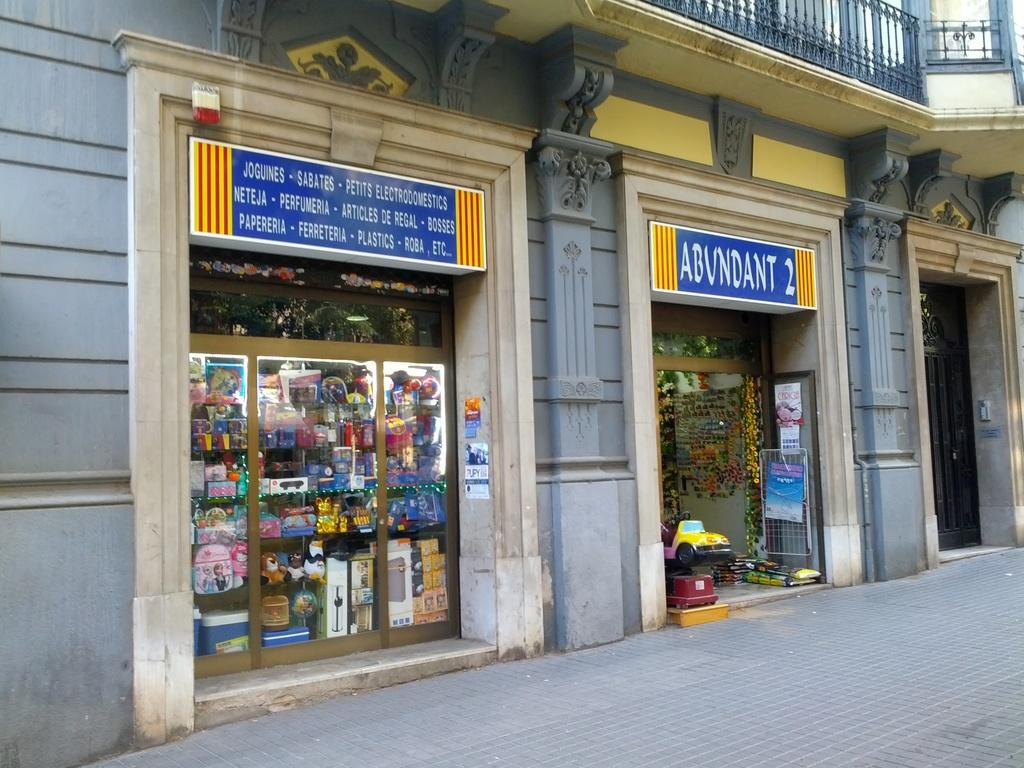<image>
Offer a succinct explanation of the picture presented. Store faces one of them reads abundant and looks to have a toy car inside. 